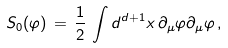<formula> <loc_0><loc_0><loc_500><loc_500>S _ { 0 } ( \varphi ) \, = \, \frac { 1 } { 2 } \, \int d ^ { d + 1 } x \, \partial _ { \mu } \varphi \partial _ { \mu } \varphi \, ,</formula> 